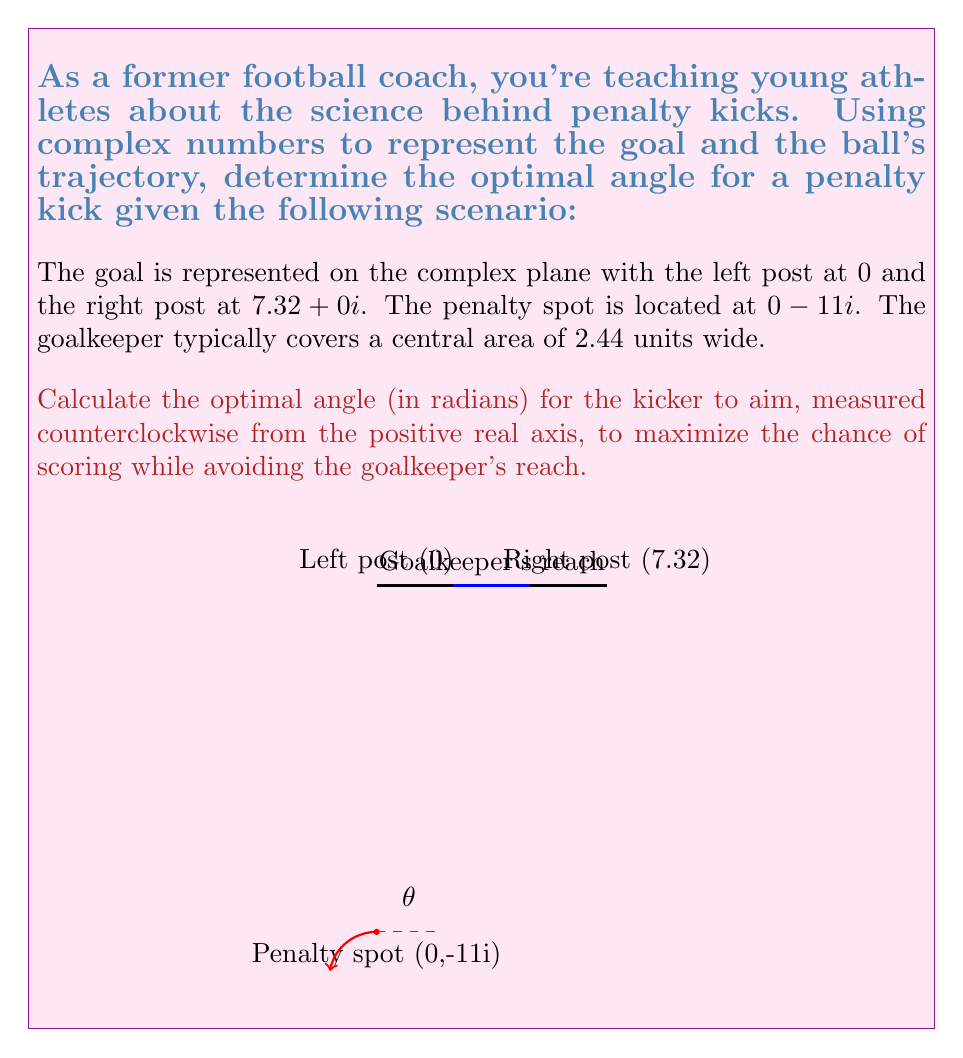Provide a solution to this math problem. Let's approach this step-by-step using complex analysis:

1) First, we need to find the points where the ball's trajectory would just graze the goalkeeper's reach. These points are at $1.22 + 0i$ and $6.1 + 0i$ on the goal line.

2) We can represent these points as complex numbers: $z_1 = 1.22$ and $z_2 = 6.1$.

3) The penalty spot is at $z_p = 0 - 11i$.

4) To find the optimal angle, we need to calculate the arguments of $z_1 - z_p$ and $z_2 - z_p$, then take their average.

5) For $z_1 - z_p$:
   $$\arg(z_1 - z_p) = \arg(1.22 + 11i) = \arctan(\frac{11}{1.22}) \approx 1.4605 \text{ radians}$$

6) For $z_2 - z_p$:
   $$\arg(z_2 - z_p) = \arg(6.1 + 11i) = \arctan(\frac{11}{6.1}) \approx 1.0637 \text{ radians}$$

7) The optimal angle is the average of these two arguments:
   $$\theta = \frac{1.4605 + 1.0637}{2} \approx 1.2621 \text{ radians}$$

This angle maximizes the chance of scoring by aiming at the midpoint between the edge of the goalkeeper's reach and the goal post, giving the keeper the least chance to save the ball.
Answer: $\theta \approx 1.2621 \text{ radians}$ 